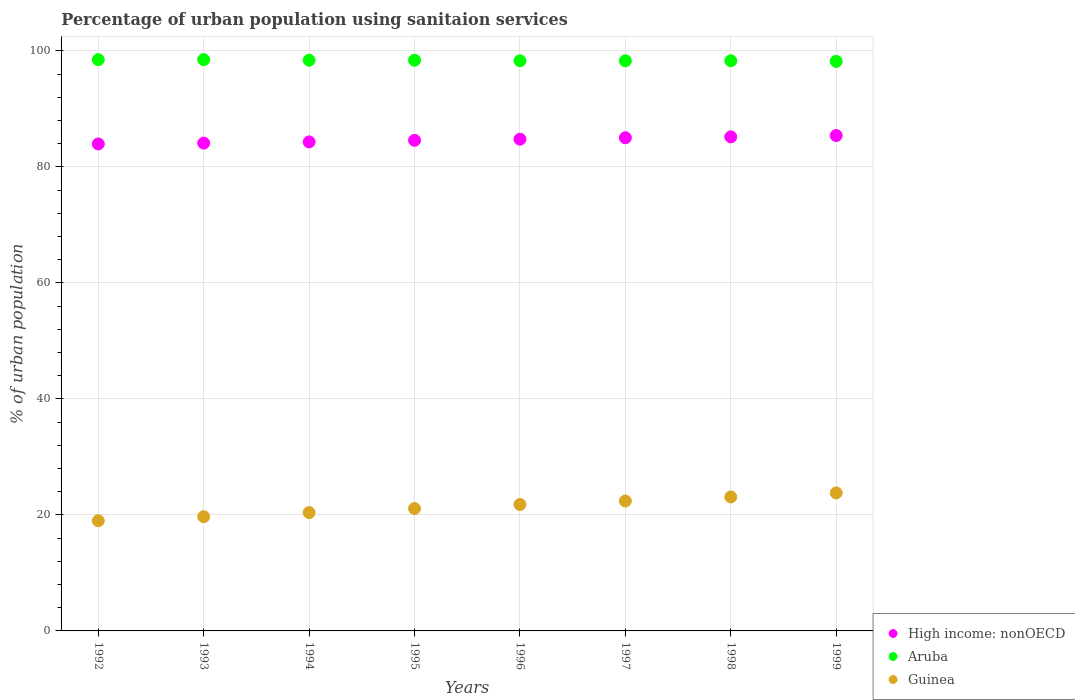Is the number of dotlines equal to the number of legend labels?
Provide a short and direct response. Yes. Across all years, what is the maximum percentage of urban population using sanitaion services in Aruba?
Your answer should be compact. 98.5. Across all years, what is the minimum percentage of urban population using sanitaion services in Aruba?
Offer a very short reply. 98.2. What is the total percentage of urban population using sanitaion services in Guinea in the graph?
Ensure brevity in your answer.  171.3. What is the difference between the percentage of urban population using sanitaion services in Aruba in 1995 and that in 1997?
Make the answer very short. 0.1. What is the difference between the percentage of urban population using sanitaion services in High income: nonOECD in 1992 and the percentage of urban population using sanitaion services in Guinea in 1996?
Your response must be concise. 62.16. What is the average percentage of urban population using sanitaion services in High income: nonOECD per year?
Make the answer very short. 84.67. In the year 1996, what is the difference between the percentage of urban population using sanitaion services in High income: nonOECD and percentage of urban population using sanitaion services in Guinea?
Your answer should be very brief. 62.98. In how many years, is the percentage of urban population using sanitaion services in Guinea greater than 12 %?
Provide a short and direct response. 8. What is the ratio of the percentage of urban population using sanitaion services in Guinea in 1993 to that in 1995?
Make the answer very short. 0.93. Is the percentage of urban population using sanitaion services in Aruba in 1995 less than that in 1997?
Ensure brevity in your answer.  No. What is the difference between the highest and the second highest percentage of urban population using sanitaion services in Guinea?
Provide a succinct answer. 0.7. What is the difference between the highest and the lowest percentage of urban population using sanitaion services in Aruba?
Your answer should be compact. 0.3. In how many years, is the percentage of urban population using sanitaion services in Guinea greater than the average percentage of urban population using sanitaion services in Guinea taken over all years?
Your answer should be compact. 4. Is it the case that in every year, the sum of the percentage of urban population using sanitaion services in High income: nonOECD and percentage of urban population using sanitaion services in Aruba  is greater than the percentage of urban population using sanitaion services in Guinea?
Keep it short and to the point. Yes. Is the percentage of urban population using sanitaion services in Aruba strictly greater than the percentage of urban population using sanitaion services in Guinea over the years?
Offer a terse response. Yes. Is the percentage of urban population using sanitaion services in Aruba strictly less than the percentage of urban population using sanitaion services in Guinea over the years?
Keep it short and to the point. No. How many years are there in the graph?
Keep it short and to the point. 8. Are the values on the major ticks of Y-axis written in scientific E-notation?
Give a very brief answer. No. Does the graph contain any zero values?
Provide a succinct answer. No. Where does the legend appear in the graph?
Offer a terse response. Bottom right. What is the title of the graph?
Your answer should be very brief. Percentage of urban population using sanitaion services. Does "Liberia" appear as one of the legend labels in the graph?
Keep it short and to the point. No. What is the label or title of the Y-axis?
Your response must be concise. % of urban population. What is the % of urban population in High income: nonOECD in 1992?
Your response must be concise. 83.96. What is the % of urban population in Aruba in 1992?
Provide a short and direct response. 98.5. What is the % of urban population of Guinea in 1992?
Make the answer very short. 19. What is the % of urban population of High income: nonOECD in 1993?
Your answer should be compact. 84.11. What is the % of urban population of Aruba in 1993?
Keep it short and to the point. 98.5. What is the % of urban population in Guinea in 1993?
Offer a very short reply. 19.7. What is the % of urban population of High income: nonOECD in 1994?
Your response must be concise. 84.31. What is the % of urban population of Aruba in 1994?
Provide a succinct answer. 98.4. What is the % of urban population in Guinea in 1994?
Give a very brief answer. 20.4. What is the % of urban population in High income: nonOECD in 1995?
Ensure brevity in your answer.  84.59. What is the % of urban population of Aruba in 1995?
Your response must be concise. 98.4. What is the % of urban population in Guinea in 1995?
Provide a succinct answer. 21.1. What is the % of urban population of High income: nonOECD in 1996?
Provide a succinct answer. 84.78. What is the % of urban population of Aruba in 1996?
Your response must be concise. 98.3. What is the % of urban population in Guinea in 1996?
Offer a very short reply. 21.8. What is the % of urban population of High income: nonOECD in 1997?
Give a very brief answer. 85.03. What is the % of urban population of Aruba in 1997?
Make the answer very short. 98.3. What is the % of urban population of Guinea in 1997?
Keep it short and to the point. 22.4. What is the % of urban population in High income: nonOECD in 1998?
Ensure brevity in your answer.  85.19. What is the % of urban population in Aruba in 1998?
Your answer should be compact. 98.3. What is the % of urban population in Guinea in 1998?
Give a very brief answer. 23.1. What is the % of urban population of High income: nonOECD in 1999?
Keep it short and to the point. 85.41. What is the % of urban population of Aruba in 1999?
Offer a terse response. 98.2. What is the % of urban population in Guinea in 1999?
Ensure brevity in your answer.  23.8. Across all years, what is the maximum % of urban population of High income: nonOECD?
Provide a short and direct response. 85.41. Across all years, what is the maximum % of urban population in Aruba?
Your answer should be compact. 98.5. Across all years, what is the maximum % of urban population in Guinea?
Make the answer very short. 23.8. Across all years, what is the minimum % of urban population in High income: nonOECD?
Your response must be concise. 83.96. Across all years, what is the minimum % of urban population in Aruba?
Ensure brevity in your answer.  98.2. Across all years, what is the minimum % of urban population of Guinea?
Your answer should be very brief. 19. What is the total % of urban population in High income: nonOECD in the graph?
Provide a short and direct response. 677.39. What is the total % of urban population of Aruba in the graph?
Keep it short and to the point. 786.9. What is the total % of urban population in Guinea in the graph?
Your answer should be compact. 171.3. What is the difference between the % of urban population of High income: nonOECD in 1992 and that in 1993?
Offer a very short reply. -0.15. What is the difference between the % of urban population of Aruba in 1992 and that in 1993?
Your answer should be compact. 0. What is the difference between the % of urban population in Guinea in 1992 and that in 1993?
Keep it short and to the point. -0.7. What is the difference between the % of urban population in High income: nonOECD in 1992 and that in 1994?
Keep it short and to the point. -0.35. What is the difference between the % of urban population of Aruba in 1992 and that in 1994?
Provide a succinct answer. 0.1. What is the difference between the % of urban population of Guinea in 1992 and that in 1994?
Keep it short and to the point. -1.4. What is the difference between the % of urban population in High income: nonOECD in 1992 and that in 1995?
Give a very brief answer. -0.62. What is the difference between the % of urban population in High income: nonOECD in 1992 and that in 1996?
Give a very brief answer. -0.82. What is the difference between the % of urban population in Guinea in 1992 and that in 1996?
Offer a very short reply. -2.8. What is the difference between the % of urban population of High income: nonOECD in 1992 and that in 1997?
Provide a short and direct response. -1.06. What is the difference between the % of urban population of Aruba in 1992 and that in 1997?
Offer a terse response. 0.2. What is the difference between the % of urban population of Guinea in 1992 and that in 1997?
Give a very brief answer. -3.4. What is the difference between the % of urban population of High income: nonOECD in 1992 and that in 1998?
Give a very brief answer. -1.22. What is the difference between the % of urban population of Guinea in 1992 and that in 1998?
Keep it short and to the point. -4.1. What is the difference between the % of urban population of High income: nonOECD in 1992 and that in 1999?
Your response must be concise. -1.45. What is the difference between the % of urban population in High income: nonOECD in 1993 and that in 1994?
Ensure brevity in your answer.  -0.2. What is the difference between the % of urban population in Aruba in 1993 and that in 1994?
Provide a succinct answer. 0.1. What is the difference between the % of urban population in High income: nonOECD in 1993 and that in 1995?
Ensure brevity in your answer.  -0.48. What is the difference between the % of urban population in Guinea in 1993 and that in 1995?
Your answer should be compact. -1.4. What is the difference between the % of urban population in High income: nonOECD in 1993 and that in 1996?
Offer a terse response. -0.67. What is the difference between the % of urban population of Guinea in 1993 and that in 1996?
Your answer should be very brief. -2.1. What is the difference between the % of urban population of High income: nonOECD in 1993 and that in 1997?
Provide a succinct answer. -0.92. What is the difference between the % of urban population in High income: nonOECD in 1993 and that in 1998?
Your answer should be very brief. -1.08. What is the difference between the % of urban population of High income: nonOECD in 1993 and that in 1999?
Provide a short and direct response. -1.3. What is the difference between the % of urban population of High income: nonOECD in 1994 and that in 1995?
Give a very brief answer. -0.28. What is the difference between the % of urban population of Aruba in 1994 and that in 1995?
Make the answer very short. 0. What is the difference between the % of urban population in Guinea in 1994 and that in 1995?
Give a very brief answer. -0.7. What is the difference between the % of urban population of High income: nonOECD in 1994 and that in 1996?
Provide a succinct answer. -0.47. What is the difference between the % of urban population in High income: nonOECD in 1994 and that in 1997?
Keep it short and to the point. -0.72. What is the difference between the % of urban population of High income: nonOECD in 1994 and that in 1998?
Provide a short and direct response. -0.88. What is the difference between the % of urban population in Aruba in 1994 and that in 1998?
Provide a short and direct response. 0.1. What is the difference between the % of urban population of High income: nonOECD in 1994 and that in 1999?
Provide a succinct answer. -1.1. What is the difference between the % of urban population of Aruba in 1994 and that in 1999?
Make the answer very short. 0.2. What is the difference between the % of urban population in High income: nonOECD in 1995 and that in 1996?
Make the answer very short. -0.19. What is the difference between the % of urban population in Aruba in 1995 and that in 1996?
Your response must be concise. 0.1. What is the difference between the % of urban population of High income: nonOECD in 1995 and that in 1997?
Ensure brevity in your answer.  -0.44. What is the difference between the % of urban population in High income: nonOECD in 1995 and that in 1998?
Offer a very short reply. -0.6. What is the difference between the % of urban population of Guinea in 1995 and that in 1998?
Your response must be concise. -2. What is the difference between the % of urban population of High income: nonOECD in 1995 and that in 1999?
Ensure brevity in your answer.  -0.83. What is the difference between the % of urban population in Aruba in 1995 and that in 1999?
Keep it short and to the point. 0.2. What is the difference between the % of urban population in High income: nonOECD in 1996 and that in 1997?
Your answer should be compact. -0.25. What is the difference between the % of urban population in Guinea in 1996 and that in 1997?
Your response must be concise. -0.6. What is the difference between the % of urban population in High income: nonOECD in 1996 and that in 1998?
Make the answer very short. -0.41. What is the difference between the % of urban population in Aruba in 1996 and that in 1998?
Your response must be concise. 0. What is the difference between the % of urban population of Guinea in 1996 and that in 1998?
Your answer should be compact. -1.3. What is the difference between the % of urban population of High income: nonOECD in 1996 and that in 1999?
Provide a short and direct response. -0.63. What is the difference between the % of urban population in Aruba in 1996 and that in 1999?
Provide a short and direct response. 0.1. What is the difference between the % of urban population in Guinea in 1996 and that in 1999?
Your answer should be very brief. -2. What is the difference between the % of urban population of High income: nonOECD in 1997 and that in 1998?
Your response must be concise. -0.16. What is the difference between the % of urban population in Guinea in 1997 and that in 1998?
Make the answer very short. -0.7. What is the difference between the % of urban population of High income: nonOECD in 1997 and that in 1999?
Offer a terse response. -0.39. What is the difference between the % of urban population of High income: nonOECD in 1998 and that in 1999?
Your response must be concise. -0.23. What is the difference between the % of urban population in Guinea in 1998 and that in 1999?
Offer a terse response. -0.7. What is the difference between the % of urban population of High income: nonOECD in 1992 and the % of urban population of Aruba in 1993?
Offer a terse response. -14.54. What is the difference between the % of urban population of High income: nonOECD in 1992 and the % of urban population of Guinea in 1993?
Provide a succinct answer. 64.26. What is the difference between the % of urban population of Aruba in 1992 and the % of urban population of Guinea in 1993?
Your answer should be compact. 78.8. What is the difference between the % of urban population of High income: nonOECD in 1992 and the % of urban population of Aruba in 1994?
Your answer should be compact. -14.44. What is the difference between the % of urban population of High income: nonOECD in 1992 and the % of urban population of Guinea in 1994?
Offer a terse response. 63.56. What is the difference between the % of urban population in Aruba in 1992 and the % of urban population in Guinea in 1994?
Keep it short and to the point. 78.1. What is the difference between the % of urban population in High income: nonOECD in 1992 and the % of urban population in Aruba in 1995?
Your answer should be compact. -14.44. What is the difference between the % of urban population of High income: nonOECD in 1992 and the % of urban population of Guinea in 1995?
Keep it short and to the point. 62.86. What is the difference between the % of urban population of Aruba in 1992 and the % of urban population of Guinea in 1995?
Ensure brevity in your answer.  77.4. What is the difference between the % of urban population in High income: nonOECD in 1992 and the % of urban population in Aruba in 1996?
Make the answer very short. -14.34. What is the difference between the % of urban population in High income: nonOECD in 1992 and the % of urban population in Guinea in 1996?
Give a very brief answer. 62.16. What is the difference between the % of urban population of Aruba in 1992 and the % of urban population of Guinea in 1996?
Your answer should be compact. 76.7. What is the difference between the % of urban population of High income: nonOECD in 1992 and the % of urban population of Aruba in 1997?
Provide a short and direct response. -14.34. What is the difference between the % of urban population of High income: nonOECD in 1992 and the % of urban population of Guinea in 1997?
Provide a short and direct response. 61.56. What is the difference between the % of urban population of Aruba in 1992 and the % of urban population of Guinea in 1997?
Offer a terse response. 76.1. What is the difference between the % of urban population of High income: nonOECD in 1992 and the % of urban population of Aruba in 1998?
Give a very brief answer. -14.34. What is the difference between the % of urban population of High income: nonOECD in 1992 and the % of urban population of Guinea in 1998?
Provide a succinct answer. 60.86. What is the difference between the % of urban population in Aruba in 1992 and the % of urban population in Guinea in 1998?
Your answer should be very brief. 75.4. What is the difference between the % of urban population in High income: nonOECD in 1992 and the % of urban population in Aruba in 1999?
Your answer should be very brief. -14.24. What is the difference between the % of urban population in High income: nonOECD in 1992 and the % of urban population in Guinea in 1999?
Keep it short and to the point. 60.16. What is the difference between the % of urban population of Aruba in 1992 and the % of urban population of Guinea in 1999?
Provide a succinct answer. 74.7. What is the difference between the % of urban population in High income: nonOECD in 1993 and the % of urban population in Aruba in 1994?
Offer a very short reply. -14.29. What is the difference between the % of urban population in High income: nonOECD in 1993 and the % of urban population in Guinea in 1994?
Offer a very short reply. 63.71. What is the difference between the % of urban population of Aruba in 1993 and the % of urban population of Guinea in 1994?
Ensure brevity in your answer.  78.1. What is the difference between the % of urban population of High income: nonOECD in 1993 and the % of urban population of Aruba in 1995?
Provide a succinct answer. -14.29. What is the difference between the % of urban population of High income: nonOECD in 1993 and the % of urban population of Guinea in 1995?
Your response must be concise. 63.01. What is the difference between the % of urban population of Aruba in 1993 and the % of urban population of Guinea in 1995?
Offer a terse response. 77.4. What is the difference between the % of urban population of High income: nonOECD in 1993 and the % of urban population of Aruba in 1996?
Make the answer very short. -14.19. What is the difference between the % of urban population in High income: nonOECD in 1993 and the % of urban population in Guinea in 1996?
Your answer should be compact. 62.31. What is the difference between the % of urban population in Aruba in 1993 and the % of urban population in Guinea in 1996?
Keep it short and to the point. 76.7. What is the difference between the % of urban population in High income: nonOECD in 1993 and the % of urban population in Aruba in 1997?
Ensure brevity in your answer.  -14.19. What is the difference between the % of urban population in High income: nonOECD in 1993 and the % of urban population in Guinea in 1997?
Offer a very short reply. 61.71. What is the difference between the % of urban population of Aruba in 1993 and the % of urban population of Guinea in 1997?
Give a very brief answer. 76.1. What is the difference between the % of urban population in High income: nonOECD in 1993 and the % of urban population in Aruba in 1998?
Make the answer very short. -14.19. What is the difference between the % of urban population in High income: nonOECD in 1993 and the % of urban population in Guinea in 1998?
Your response must be concise. 61.01. What is the difference between the % of urban population of Aruba in 1993 and the % of urban population of Guinea in 1998?
Offer a very short reply. 75.4. What is the difference between the % of urban population of High income: nonOECD in 1993 and the % of urban population of Aruba in 1999?
Ensure brevity in your answer.  -14.09. What is the difference between the % of urban population of High income: nonOECD in 1993 and the % of urban population of Guinea in 1999?
Provide a succinct answer. 60.31. What is the difference between the % of urban population of Aruba in 1993 and the % of urban population of Guinea in 1999?
Your response must be concise. 74.7. What is the difference between the % of urban population of High income: nonOECD in 1994 and the % of urban population of Aruba in 1995?
Provide a short and direct response. -14.09. What is the difference between the % of urban population of High income: nonOECD in 1994 and the % of urban population of Guinea in 1995?
Offer a very short reply. 63.21. What is the difference between the % of urban population in Aruba in 1994 and the % of urban population in Guinea in 1995?
Your answer should be compact. 77.3. What is the difference between the % of urban population in High income: nonOECD in 1994 and the % of urban population in Aruba in 1996?
Your response must be concise. -13.99. What is the difference between the % of urban population in High income: nonOECD in 1994 and the % of urban population in Guinea in 1996?
Your response must be concise. 62.51. What is the difference between the % of urban population of Aruba in 1994 and the % of urban population of Guinea in 1996?
Offer a very short reply. 76.6. What is the difference between the % of urban population of High income: nonOECD in 1994 and the % of urban population of Aruba in 1997?
Give a very brief answer. -13.99. What is the difference between the % of urban population in High income: nonOECD in 1994 and the % of urban population in Guinea in 1997?
Ensure brevity in your answer.  61.91. What is the difference between the % of urban population of Aruba in 1994 and the % of urban population of Guinea in 1997?
Ensure brevity in your answer.  76. What is the difference between the % of urban population in High income: nonOECD in 1994 and the % of urban population in Aruba in 1998?
Ensure brevity in your answer.  -13.99. What is the difference between the % of urban population in High income: nonOECD in 1994 and the % of urban population in Guinea in 1998?
Offer a very short reply. 61.21. What is the difference between the % of urban population of Aruba in 1994 and the % of urban population of Guinea in 1998?
Your answer should be compact. 75.3. What is the difference between the % of urban population in High income: nonOECD in 1994 and the % of urban population in Aruba in 1999?
Provide a short and direct response. -13.89. What is the difference between the % of urban population of High income: nonOECD in 1994 and the % of urban population of Guinea in 1999?
Give a very brief answer. 60.51. What is the difference between the % of urban population of Aruba in 1994 and the % of urban population of Guinea in 1999?
Your response must be concise. 74.6. What is the difference between the % of urban population of High income: nonOECD in 1995 and the % of urban population of Aruba in 1996?
Provide a succinct answer. -13.71. What is the difference between the % of urban population of High income: nonOECD in 1995 and the % of urban population of Guinea in 1996?
Give a very brief answer. 62.79. What is the difference between the % of urban population of Aruba in 1995 and the % of urban population of Guinea in 1996?
Your answer should be very brief. 76.6. What is the difference between the % of urban population in High income: nonOECD in 1995 and the % of urban population in Aruba in 1997?
Ensure brevity in your answer.  -13.71. What is the difference between the % of urban population of High income: nonOECD in 1995 and the % of urban population of Guinea in 1997?
Your response must be concise. 62.19. What is the difference between the % of urban population in Aruba in 1995 and the % of urban population in Guinea in 1997?
Provide a succinct answer. 76. What is the difference between the % of urban population of High income: nonOECD in 1995 and the % of urban population of Aruba in 1998?
Your response must be concise. -13.71. What is the difference between the % of urban population in High income: nonOECD in 1995 and the % of urban population in Guinea in 1998?
Give a very brief answer. 61.49. What is the difference between the % of urban population of Aruba in 1995 and the % of urban population of Guinea in 1998?
Offer a terse response. 75.3. What is the difference between the % of urban population in High income: nonOECD in 1995 and the % of urban population in Aruba in 1999?
Ensure brevity in your answer.  -13.61. What is the difference between the % of urban population in High income: nonOECD in 1995 and the % of urban population in Guinea in 1999?
Ensure brevity in your answer.  60.79. What is the difference between the % of urban population in Aruba in 1995 and the % of urban population in Guinea in 1999?
Your response must be concise. 74.6. What is the difference between the % of urban population in High income: nonOECD in 1996 and the % of urban population in Aruba in 1997?
Keep it short and to the point. -13.52. What is the difference between the % of urban population of High income: nonOECD in 1996 and the % of urban population of Guinea in 1997?
Ensure brevity in your answer.  62.38. What is the difference between the % of urban population in Aruba in 1996 and the % of urban population in Guinea in 1997?
Give a very brief answer. 75.9. What is the difference between the % of urban population of High income: nonOECD in 1996 and the % of urban population of Aruba in 1998?
Offer a terse response. -13.52. What is the difference between the % of urban population in High income: nonOECD in 1996 and the % of urban population in Guinea in 1998?
Ensure brevity in your answer.  61.68. What is the difference between the % of urban population in Aruba in 1996 and the % of urban population in Guinea in 1998?
Make the answer very short. 75.2. What is the difference between the % of urban population in High income: nonOECD in 1996 and the % of urban population in Aruba in 1999?
Provide a succinct answer. -13.42. What is the difference between the % of urban population of High income: nonOECD in 1996 and the % of urban population of Guinea in 1999?
Your answer should be compact. 60.98. What is the difference between the % of urban population in Aruba in 1996 and the % of urban population in Guinea in 1999?
Ensure brevity in your answer.  74.5. What is the difference between the % of urban population in High income: nonOECD in 1997 and the % of urban population in Aruba in 1998?
Ensure brevity in your answer.  -13.27. What is the difference between the % of urban population of High income: nonOECD in 1997 and the % of urban population of Guinea in 1998?
Offer a very short reply. 61.93. What is the difference between the % of urban population of Aruba in 1997 and the % of urban population of Guinea in 1998?
Make the answer very short. 75.2. What is the difference between the % of urban population in High income: nonOECD in 1997 and the % of urban population in Aruba in 1999?
Give a very brief answer. -13.17. What is the difference between the % of urban population of High income: nonOECD in 1997 and the % of urban population of Guinea in 1999?
Keep it short and to the point. 61.23. What is the difference between the % of urban population in Aruba in 1997 and the % of urban population in Guinea in 1999?
Provide a succinct answer. 74.5. What is the difference between the % of urban population in High income: nonOECD in 1998 and the % of urban population in Aruba in 1999?
Your answer should be compact. -13.01. What is the difference between the % of urban population of High income: nonOECD in 1998 and the % of urban population of Guinea in 1999?
Provide a succinct answer. 61.39. What is the difference between the % of urban population in Aruba in 1998 and the % of urban population in Guinea in 1999?
Your answer should be compact. 74.5. What is the average % of urban population in High income: nonOECD per year?
Keep it short and to the point. 84.67. What is the average % of urban population of Aruba per year?
Your answer should be very brief. 98.36. What is the average % of urban population of Guinea per year?
Give a very brief answer. 21.41. In the year 1992, what is the difference between the % of urban population of High income: nonOECD and % of urban population of Aruba?
Make the answer very short. -14.54. In the year 1992, what is the difference between the % of urban population in High income: nonOECD and % of urban population in Guinea?
Provide a succinct answer. 64.96. In the year 1992, what is the difference between the % of urban population in Aruba and % of urban population in Guinea?
Offer a very short reply. 79.5. In the year 1993, what is the difference between the % of urban population of High income: nonOECD and % of urban population of Aruba?
Provide a short and direct response. -14.39. In the year 1993, what is the difference between the % of urban population of High income: nonOECD and % of urban population of Guinea?
Your response must be concise. 64.41. In the year 1993, what is the difference between the % of urban population in Aruba and % of urban population in Guinea?
Your response must be concise. 78.8. In the year 1994, what is the difference between the % of urban population of High income: nonOECD and % of urban population of Aruba?
Your response must be concise. -14.09. In the year 1994, what is the difference between the % of urban population in High income: nonOECD and % of urban population in Guinea?
Provide a succinct answer. 63.91. In the year 1995, what is the difference between the % of urban population in High income: nonOECD and % of urban population in Aruba?
Keep it short and to the point. -13.81. In the year 1995, what is the difference between the % of urban population of High income: nonOECD and % of urban population of Guinea?
Ensure brevity in your answer.  63.49. In the year 1995, what is the difference between the % of urban population in Aruba and % of urban population in Guinea?
Offer a terse response. 77.3. In the year 1996, what is the difference between the % of urban population of High income: nonOECD and % of urban population of Aruba?
Give a very brief answer. -13.52. In the year 1996, what is the difference between the % of urban population in High income: nonOECD and % of urban population in Guinea?
Offer a very short reply. 62.98. In the year 1996, what is the difference between the % of urban population in Aruba and % of urban population in Guinea?
Provide a succinct answer. 76.5. In the year 1997, what is the difference between the % of urban population of High income: nonOECD and % of urban population of Aruba?
Keep it short and to the point. -13.27. In the year 1997, what is the difference between the % of urban population in High income: nonOECD and % of urban population in Guinea?
Provide a succinct answer. 62.63. In the year 1997, what is the difference between the % of urban population in Aruba and % of urban population in Guinea?
Your answer should be compact. 75.9. In the year 1998, what is the difference between the % of urban population of High income: nonOECD and % of urban population of Aruba?
Provide a short and direct response. -13.11. In the year 1998, what is the difference between the % of urban population of High income: nonOECD and % of urban population of Guinea?
Provide a succinct answer. 62.09. In the year 1998, what is the difference between the % of urban population in Aruba and % of urban population in Guinea?
Provide a succinct answer. 75.2. In the year 1999, what is the difference between the % of urban population of High income: nonOECD and % of urban population of Aruba?
Ensure brevity in your answer.  -12.79. In the year 1999, what is the difference between the % of urban population of High income: nonOECD and % of urban population of Guinea?
Provide a succinct answer. 61.61. In the year 1999, what is the difference between the % of urban population in Aruba and % of urban population in Guinea?
Your response must be concise. 74.4. What is the ratio of the % of urban population in Guinea in 1992 to that in 1993?
Your answer should be compact. 0.96. What is the ratio of the % of urban population of Aruba in 1992 to that in 1994?
Make the answer very short. 1. What is the ratio of the % of urban population in Guinea in 1992 to that in 1994?
Make the answer very short. 0.93. What is the ratio of the % of urban population of Guinea in 1992 to that in 1995?
Your response must be concise. 0.9. What is the ratio of the % of urban population of High income: nonOECD in 1992 to that in 1996?
Ensure brevity in your answer.  0.99. What is the ratio of the % of urban population of Guinea in 1992 to that in 1996?
Ensure brevity in your answer.  0.87. What is the ratio of the % of urban population of High income: nonOECD in 1992 to that in 1997?
Your answer should be compact. 0.99. What is the ratio of the % of urban population of Aruba in 1992 to that in 1997?
Your answer should be compact. 1. What is the ratio of the % of urban population of Guinea in 1992 to that in 1997?
Your response must be concise. 0.85. What is the ratio of the % of urban population in High income: nonOECD in 1992 to that in 1998?
Offer a terse response. 0.99. What is the ratio of the % of urban population of Guinea in 1992 to that in 1998?
Your response must be concise. 0.82. What is the ratio of the % of urban population in Aruba in 1992 to that in 1999?
Provide a succinct answer. 1. What is the ratio of the % of urban population of Guinea in 1992 to that in 1999?
Your answer should be compact. 0.8. What is the ratio of the % of urban population in Aruba in 1993 to that in 1994?
Your answer should be very brief. 1. What is the ratio of the % of urban population of Guinea in 1993 to that in 1994?
Provide a succinct answer. 0.97. What is the ratio of the % of urban population in High income: nonOECD in 1993 to that in 1995?
Your answer should be compact. 0.99. What is the ratio of the % of urban population in Guinea in 1993 to that in 1995?
Provide a short and direct response. 0.93. What is the ratio of the % of urban population in Guinea in 1993 to that in 1996?
Give a very brief answer. 0.9. What is the ratio of the % of urban population in High income: nonOECD in 1993 to that in 1997?
Your answer should be very brief. 0.99. What is the ratio of the % of urban population of Guinea in 1993 to that in 1997?
Ensure brevity in your answer.  0.88. What is the ratio of the % of urban population in High income: nonOECD in 1993 to that in 1998?
Give a very brief answer. 0.99. What is the ratio of the % of urban population in Aruba in 1993 to that in 1998?
Your answer should be very brief. 1. What is the ratio of the % of urban population in Guinea in 1993 to that in 1998?
Your response must be concise. 0.85. What is the ratio of the % of urban population of High income: nonOECD in 1993 to that in 1999?
Your response must be concise. 0.98. What is the ratio of the % of urban population in Aruba in 1993 to that in 1999?
Provide a short and direct response. 1. What is the ratio of the % of urban population in Guinea in 1993 to that in 1999?
Ensure brevity in your answer.  0.83. What is the ratio of the % of urban population of High income: nonOECD in 1994 to that in 1995?
Your response must be concise. 1. What is the ratio of the % of urban population of Aruba in 1994 to that in 1995?
Your answer should be very brief. 1. What is the ratio of the % of urban population in Guinea in 1994 to that in 1995?
Provide a succinct answer. 0.97. What is the ratio of the % of urban population of Guinea in 1994 to that in 1996?
Your response must be concise. 0.94. What is the ratio of the % of urban population of High income: nonOECD in 1994 to that in 1997?
Your answer should be compact. 0.99. What is the ratio of the % of urban population in Aruba in 1994 to that in 1997?
Give a very brief answer. 1. What is the ratio of the % of urban population of Guinea in 1994 to that in 1997?
Your answer should be very brief. 0.91. What is the ratio of the % of urban population of High income: nonOECD in 1994 to that in 1998?
Your answer should be very brief. 0.99. What is the ratio of the % of urban population in Guinea in 1994 to that in 1998?
Give a very brief answer. 0.88. What is the ratio of the % of urban population of High income: nonOECD in 1994 to that in 1999?
Keep it short and to the point. 0.99. What is the ratio of the % of urban population in Guinea in 1994 to that in 1999?
Make the answer very short. 0.86. What is the ratio of the % of urban population of Guinea in 1995 to that in 1996?
Make the answer very short. 0.97. What is the ratio of the % of urban population in High income: nonOECD in 1995 to that in 1997?
Your answer should be compact. 0.99. What is the ratio of the % of urban population of Guinea in 1995 to that in 1997?
Your answer should be compact. 0.94. What is the ratio of the % of urban population of High income: nonOECD in 1995 to that in 1998?
Your answer should be compact. 0.99. What is the ratio of the % of urban population of Aruba in 1995 to that in 1998?
Your answer should be compact. 1. What is the ratio of the % of urban population of Guinea in 1995 to that in 1998?
Provide a short and direct response. 0.91. What is the ratio of the % of urban population of High income: nonOECD in 1995 to that in 1999?
Provide a succinct answer. 0.99. What is the ratio of the % of urban population of Aruba in 1995 to that in 1999?
Make the answer very short. 1. What is the ratio of the % of urban population of Guinea in 1995 to that in 1999?
Provide a succinct answer. 0.89. What is the ratio of the % of urban population of High income: nonOECD in 1996 to that in 1997?
Provide a succinct answer. 1. What is the ratio of the % of urban population of Aruba in 1996 to that in 1997?
Offer a very short reply. 1. What is the ratio of the % of urban population in Guinea in 1996 to that in 1997?
Make the answer very short. 0.97. What is the ratio of the % of urban population of Guinea in 1996 to that in 1998?
Ensure brevity in your answer.  0.94. What is the ratio of the % of urban population in High income: nonOECD in 1996 to that in 1999?
Ensure brevity in your answer.  0.99. What is the ratio of the % of urban population of Aruba in 1996 to that in 1999?
Keep it short and to the point. 1. What is the ratio of the % of urban population of Guinea in 1996 to that in 1999?
Ensure brevity in your answer.  0.92. What is the ratio of the % of urban population of High income: nonOECD in 1997 to that in 1998?
Provide a succinct answer. 1. What is the ratio of the % of urban population in Aruba in 1997 to that in 1998?
Provide a succinct answer. 1. What is the ratio of the % of urban population of Guinea in 1997 to that in 1998?
Your answer should be very brief. 0.97. What is the ratio of the % of urban population of Aruba in 1997 to that in 1999?
Make the answer very short. 1. What is the ratio of the % of urban population of Aruba in 1998 to that in 1999?
Provide a short and direct response. 1. What is the ratio of the % of urban population in Guinea in 1998 to that in 1999?
Your answer should be compact. 0.97. What is the difference between the highest and the second highest % of urban population in High income: nonOECD?
Your response must be concise. 0.23. What is the difference between the highest and the second highest % of urban population in Aruba?
Your response must be concise. 0. What is the difference between the highest and the second highest % of urban population in Guinea?
Give a very brief answer. 0.7. What is the difference between the highest and the lowest % of urban population in High income: nonOECD?
Provide a short and direct response. 1.45. What is the difference between the highest and the lowest % of urban population of Aruba?
Give a very brief answer. 0.3. 